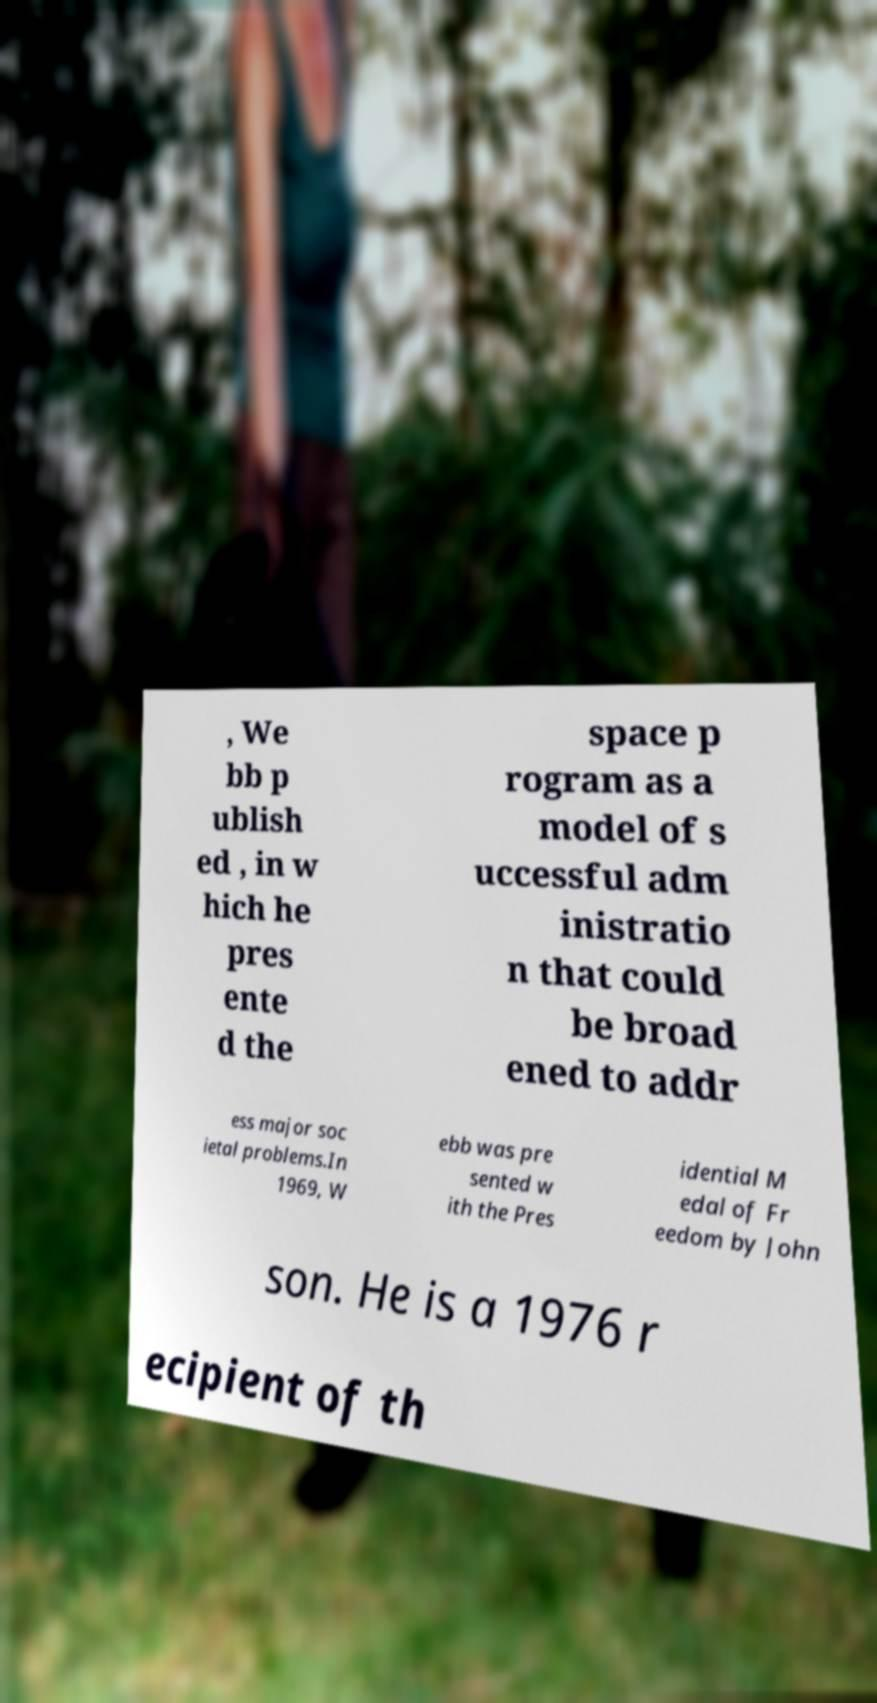For documentation purposes, I need the text within this image transcribed. Could you provide that? , We bb p ublish ed , in w hich he pres ente d the space p rogram as a model of s uccessful adm inistratio n that could be broad ened to addr ess major soc ietal problems.In 1969, W ebb was pre sented w ith the Pres idential M edal of Fr eedom by John son. He is a 1976 r ecipient of th 